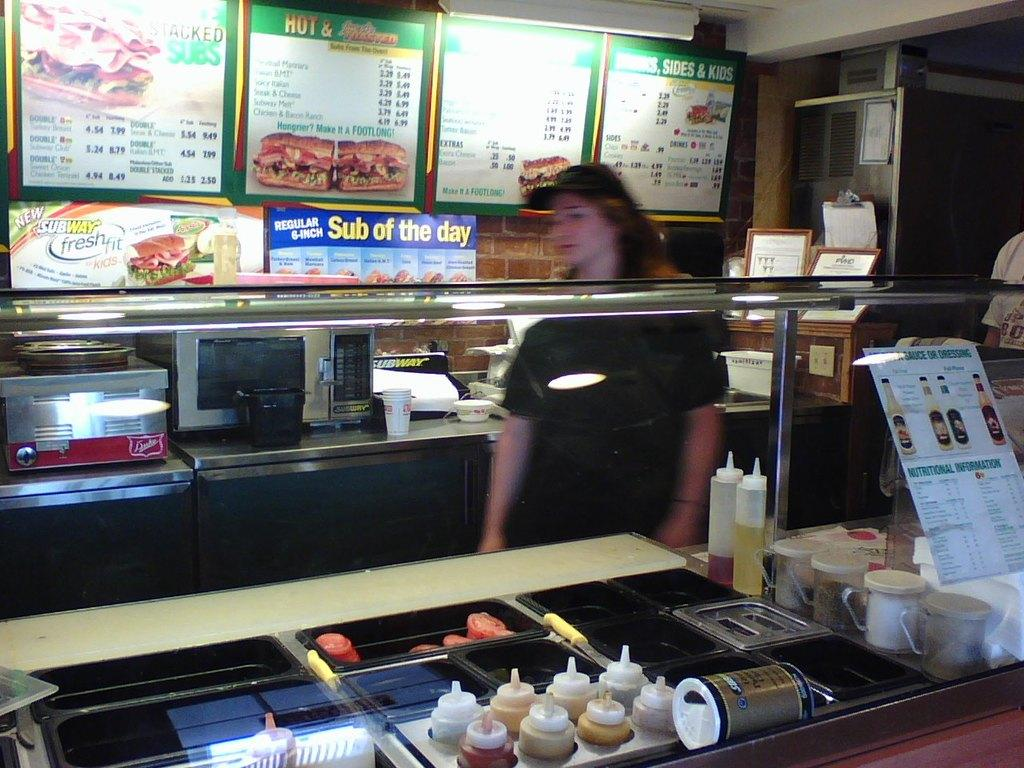<image>
Share a concise interpretation of the image provided. A woman behind a counter of a store that sells subs of the day. 